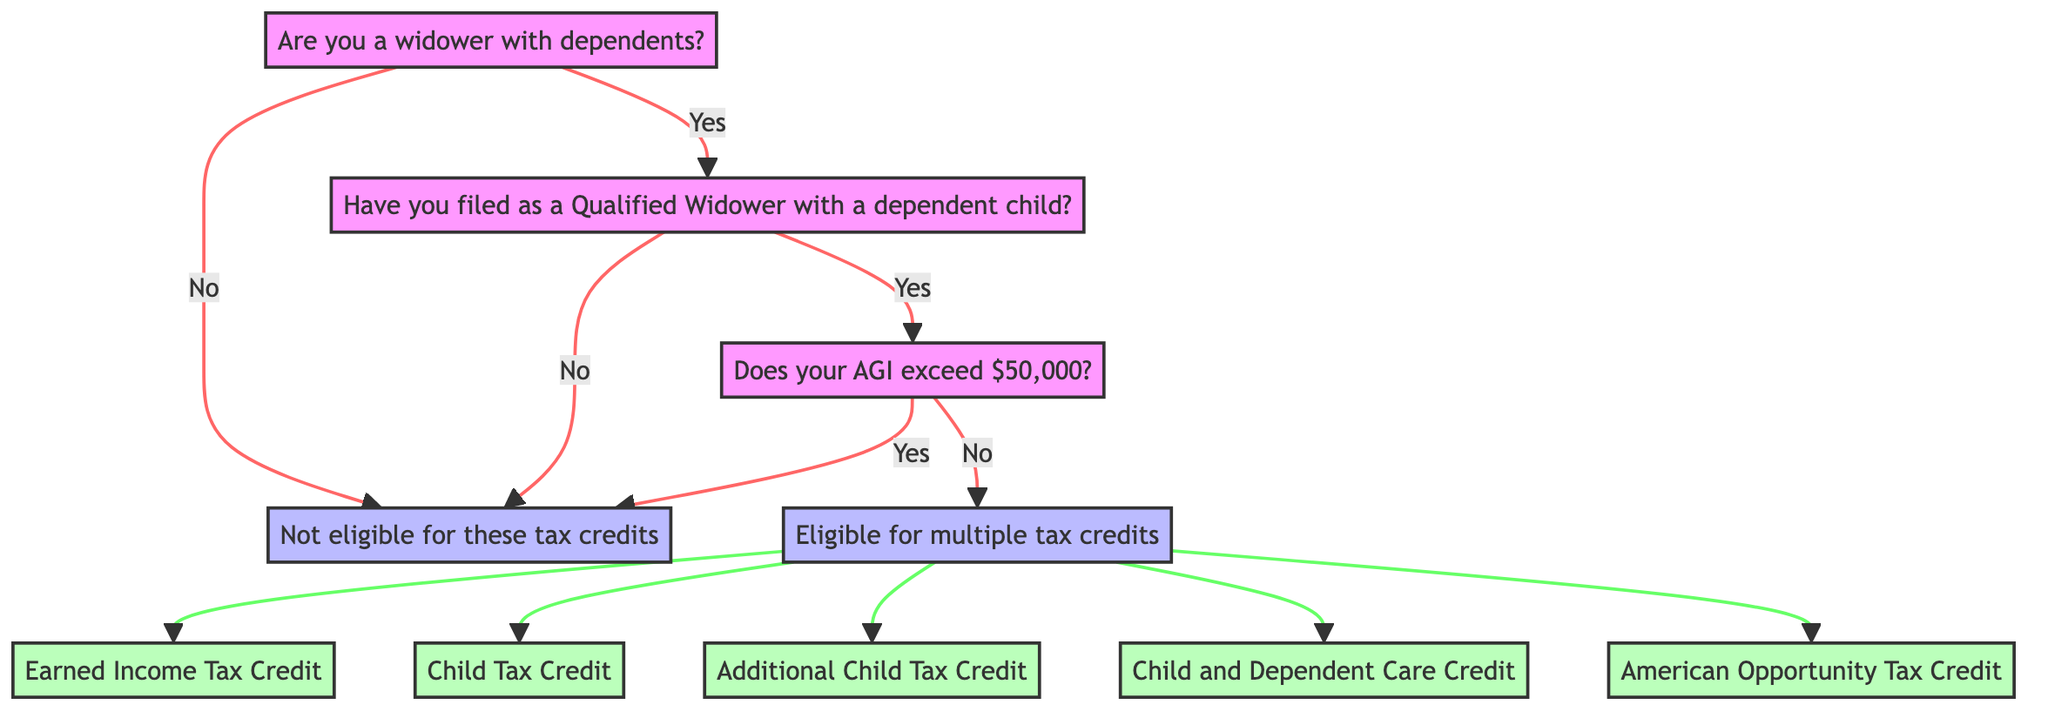Are you a widower with dependents? This is the primary question at the beginning of the decision tree. The outcome of this question determines whether the person qualifies for further inquiries about tax credits.
Answer: Yes or No Have you filed as a Qualified Widower with a dependent child? This question is asked if the previous answer is "Yes". It narrows down the eligibility, focusing specifically on the filing status of the individual.
Answer: Yes or No Does your adjusted gross income (AGI) exceed $50,000? This question arises after answering "Yes" to the previous question. It further narrows down eligibility based on income criteria.
Answer: Yes or No What tax credits are available if your AGI is less than $50,000? This question pertains to the situation where the AGI does not exceed $50,000 and multiple potential tax credits can be claimed. The diagram lists the specific credits available.
Answer: Earned Income Tax Credit, Child Tax Credit, Additional Child Tax Credit, Child and Dependent Care Credit, American Opportunity Tax Credit What happens if you answer "Yes" to having an AGI over $50,000? This question requires understanding the flow of the decision tree; answering "Yes" to this question leads to being ineligible for any additional tax credits.
Answer: Not eligible for these tax credits How many potential tax credits are there if you qualify under the income threshold? By reviewing the node that lists tax credits available when AGI is below $50,000, we find a total of five different tax credits.
Answer: Five 